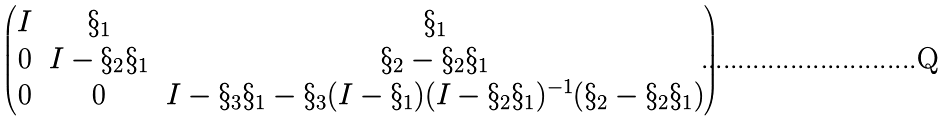Convert formula to latex. <formula><loc_0><loc_0><loc_500><loc_500>\begin{pmatrix} I & \S _ { 1 } & \S _ { 1 } \\ 0 & I - \S _ { 2 } \S _ { 1 } & \S _ { 2 } - \S _ { 2 } \S _ { 1 } \\ 0 & 0 & I - \S _ { 3 } \S _ { 1 } - \S _ { 3 } ( I - \S _ { 1 } ) ( I - \S _ { 2 } \S _ { 1 } ) ^ { - 1 } ( \S _ { 2 } - \S _ { 2 } \S _ { 1 } ) \end{pmatrix}</formula> 